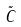<formula> <loc_0><loc_0><loc_500><loc_500>\tilde { C }</formula> 